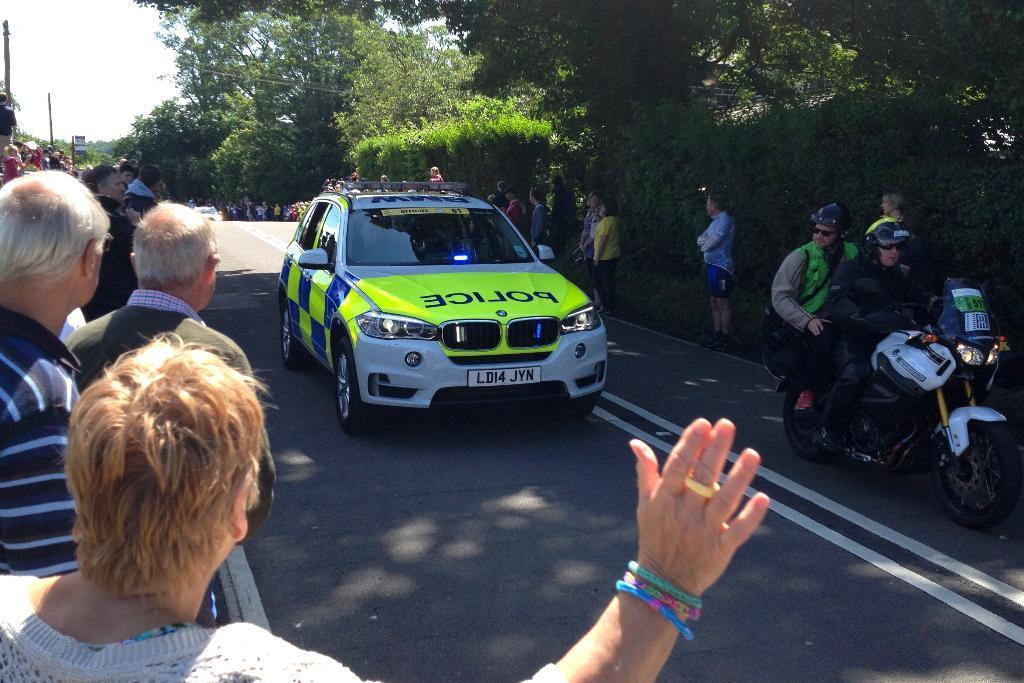Can you describe this image briefly? In this picture we can see a car on the road. There are two persons on the bike. Here we can see some persons standing on the road. These are the trees. And there is a sky. 